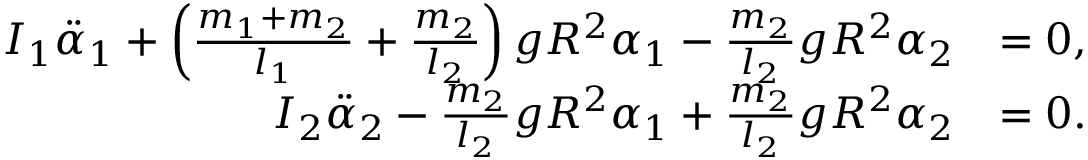Convert formula to latex. <formula><loc_0><loc_0><loc_500><loc_500>\begin{array} { r l } { I _ { 1 } \ddot { \alpha } _ { 1 } + \left ( \frac { m _ { 1 } + m _ { 2 } } { l _ { 1 } } + \frac { m _ { 2 } } { l _ { 2 } } \right ) g R ^ { 2 } \alpha _ { 1 } - \frac { m _ { 2 } } { l _ { 2 } } g R ^ { 2 } \alpha _ { 2 } } & { = 0 , } \\ { I _ { 2 } \ddot { \alpha } _ { 2 } - \frac { m _ { 2 } } { l _ { 2 } } g R ^ { 2 } \alpha _ { 1 } + \frac { m _ { 2 } } { l _ { 2 } } g R ^ { 2 } \alpha _ { 2 } } & { = 0 . } \end{array}</formula> 